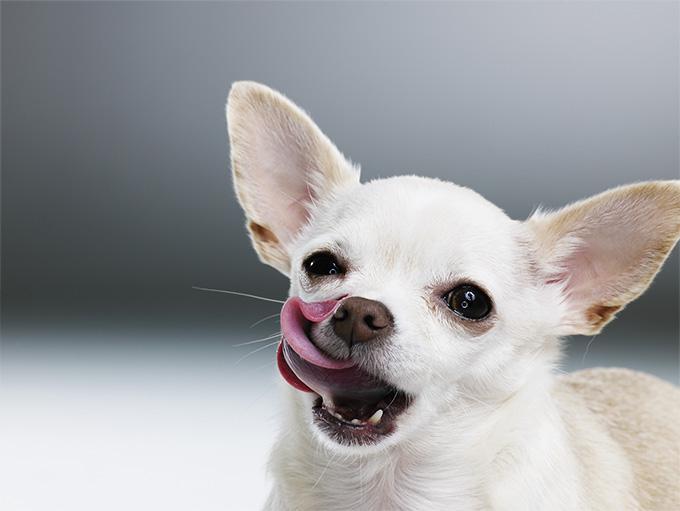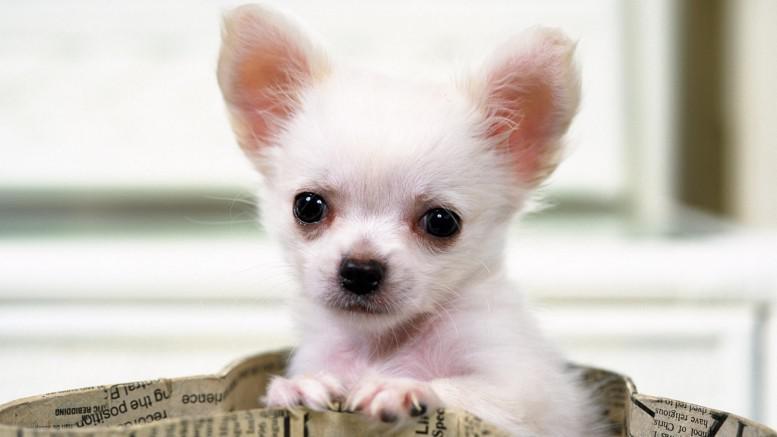The first image is the image on the left, the second image is the image on the right. Given the left and right images, does the statement "A person's hand is shown in one of the images." hold true? Answer yes or no. No. 